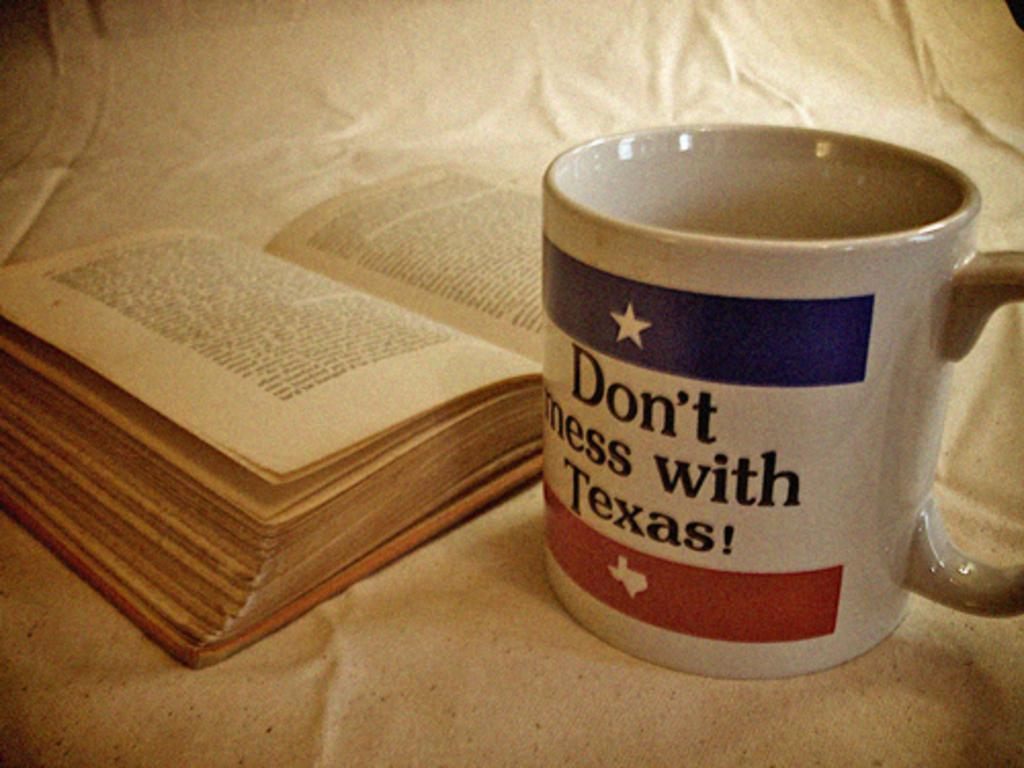<image>
Describe the image concisely. a cup that says to not mess with Texas next to a book 